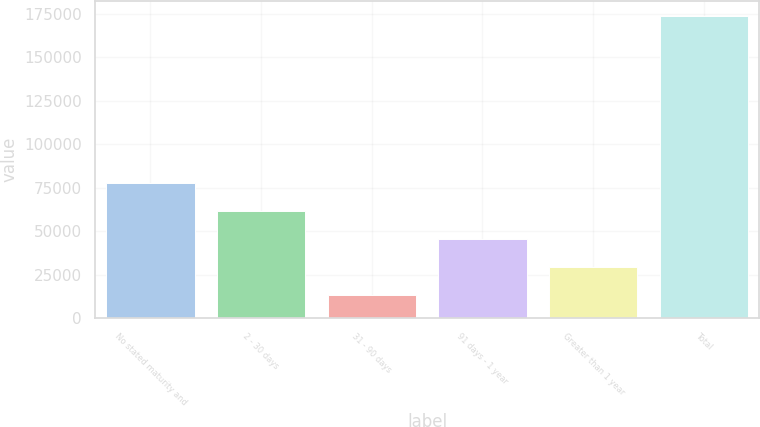<chart> <loc_0><loc_0><loc_500><loc_500><bar_chart><fcel>No stated maturity and<fcel>2 - 30 days<fcel>31 - 90 days<fcel>91 days - 1 year<fcel>Greater than 1 year<fcel>Total<nl><fcel>77640.6<fcel>61602.7<fcel>13489<fcel>45564.8<fcel>29526.9<fcel>173868<nl></chart> 